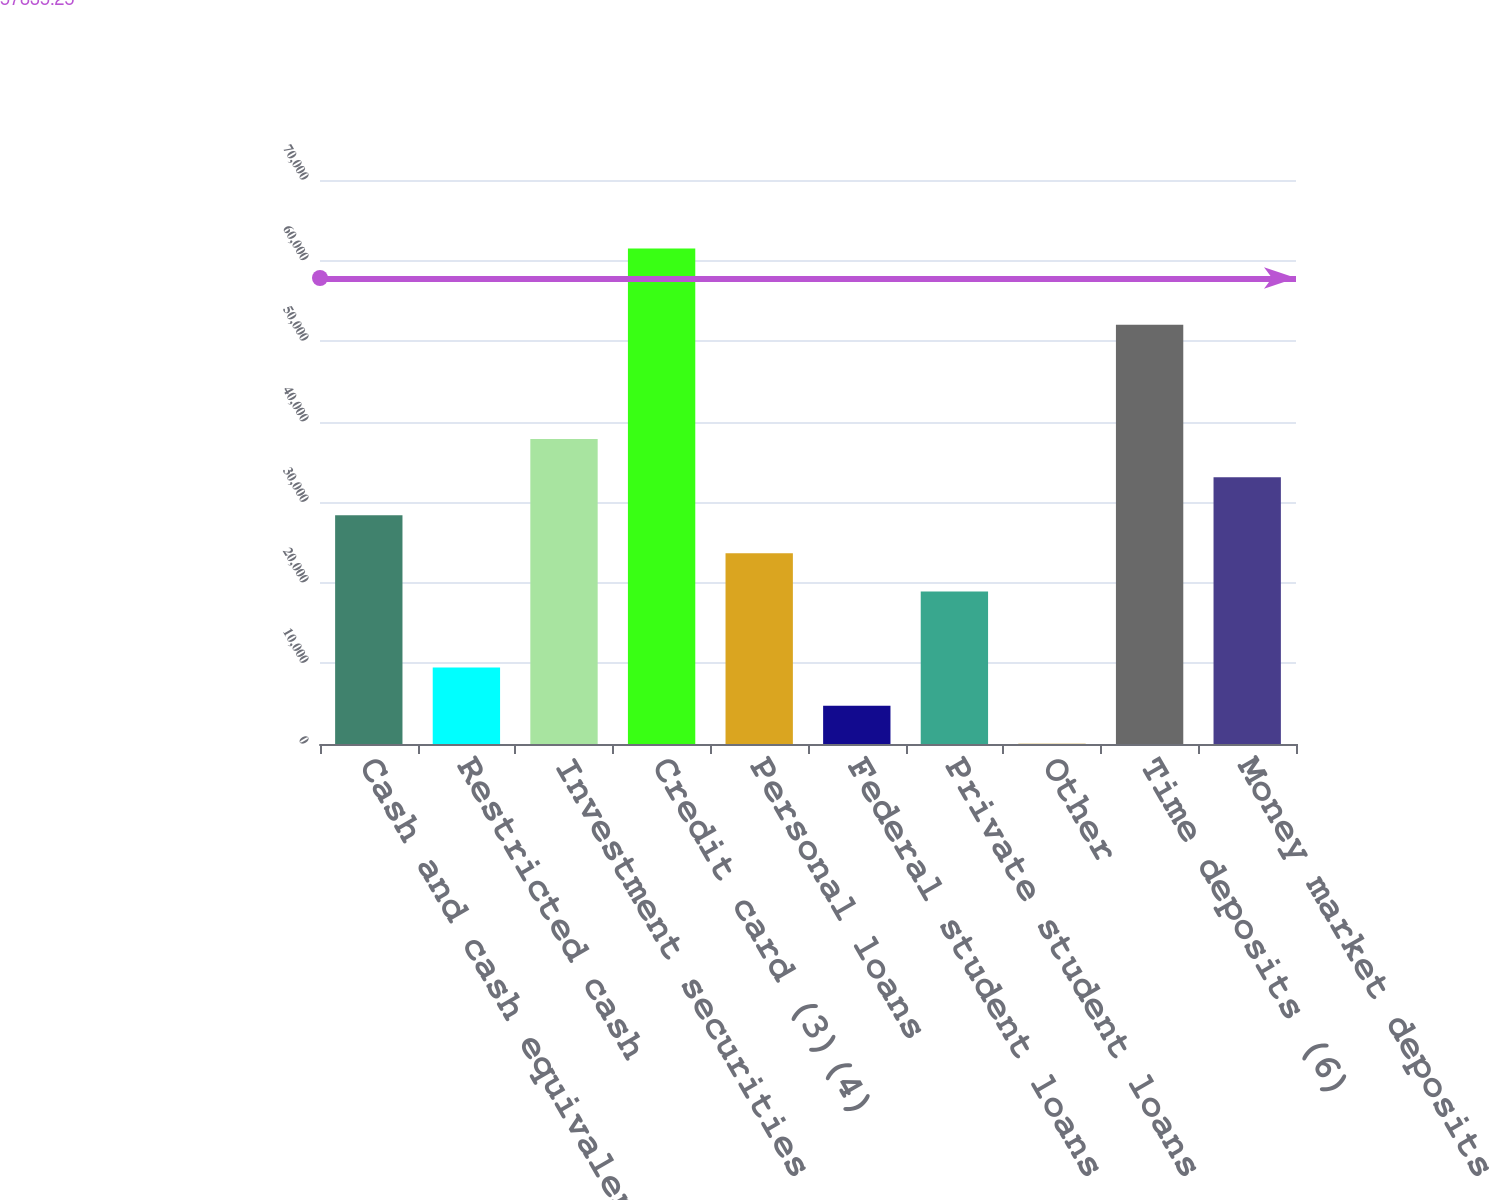<chart> <loc_0><loc_0><loc_500><loc_500><bar_chart><fcel>Cash and cash equivalents<fcel>Restricted cash<fcel>Investment securities<fcel>Credit card (3)(4)<fcel>Personal loans<fcel>Federal student loans (5)<fcel>Private student loans<fcel>Other<fcel>Time deposits (6)<fcel>Money market deposits<nl><fcel>28391<fcel>9481<fcel>37846<fcel>61483.5<fcel>23663.5<fcel>4753.5<fcel>18936<fcel>26<fcel>52028.5<fcel>33118.5<nl></chart> 